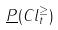Convert formula to latex. <formula><loc_0><loc_0><loc_500><loc_500>\underline { P } ( C l _ { t } ^ { \geq } )</formula> 